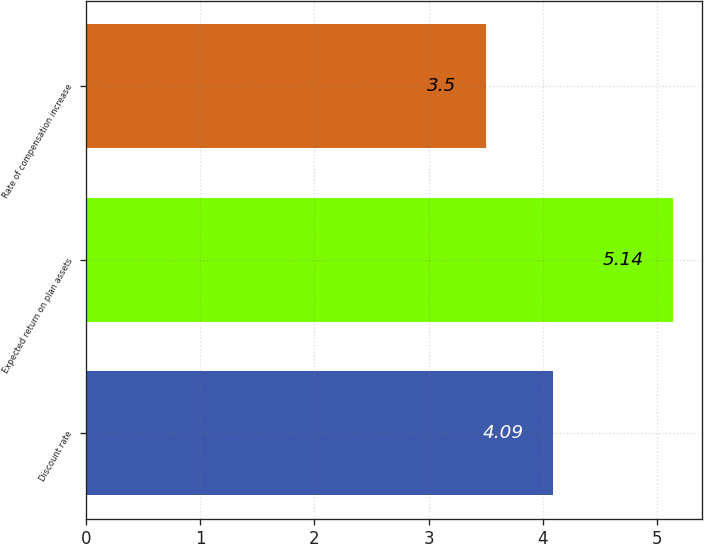Convert chart to OTSL. <chart><loc_0><loc_0><loc_500><loc_500><bar_chart><fcel>Discount rate<fcel>Expected return on plan assets<fcel>Rate of compensation increase<nl><fcel>4.09<fcel>5.14<fcel>3.5<nl></chart> 